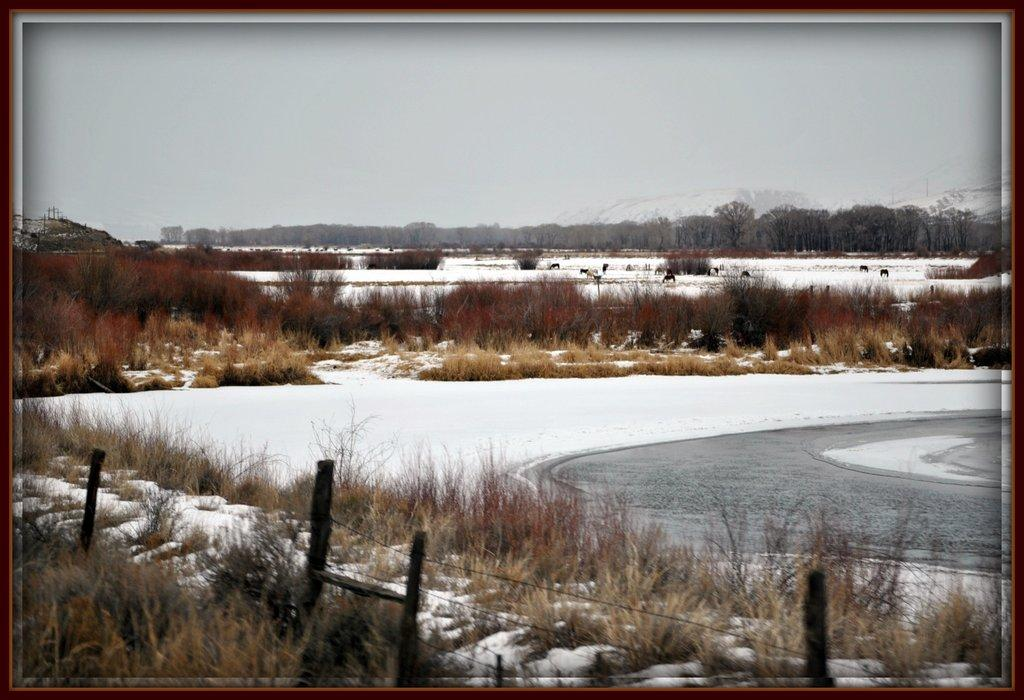What is located at the bottom of the image? There is a fence at the bottom of the image. What type of vegetation can be seen in the image? There is grass in the image. What weather condition is depicted in the image? There is snow in the image. What can be seen in the background of the image? There are trees, water, animals, grass, and mountains in the background of the image. What is visible in the sky? There are clouds in the sky. What type of chalk is being used by the animals in the image? There is no chalk present in the image, and the animals are not using any chalk. What is the desire of the crib in the image? There is no crib present in the image, and therefore no desire can be attributed to it. 